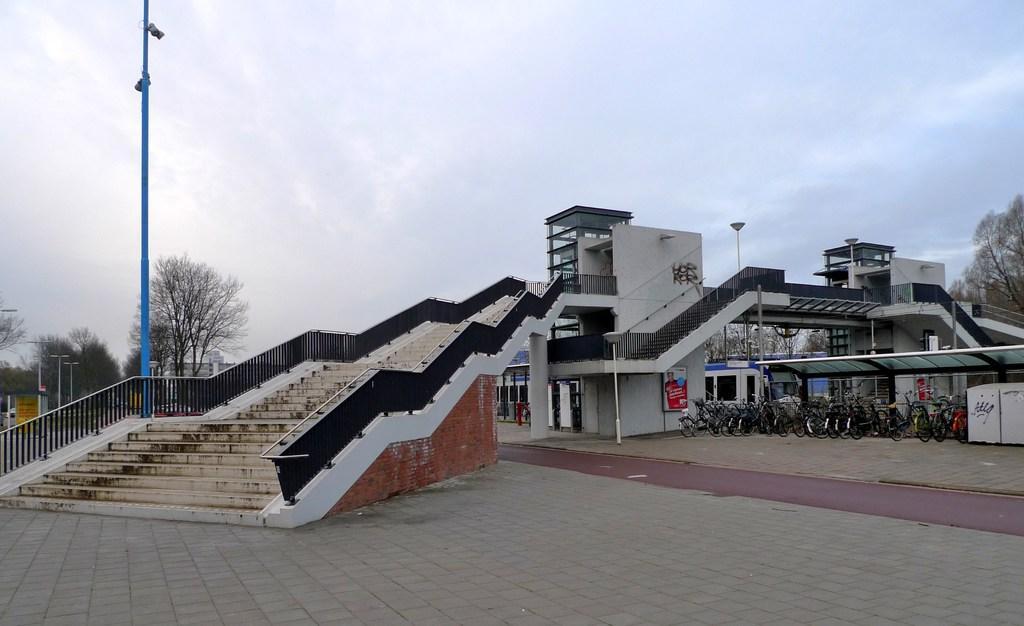Could you give a brief overview of what you see in this image? In this image we can see a building with windows. We can also see the staircase, a group of bicycles parked aside, some poles, a group of trees and the sky. 